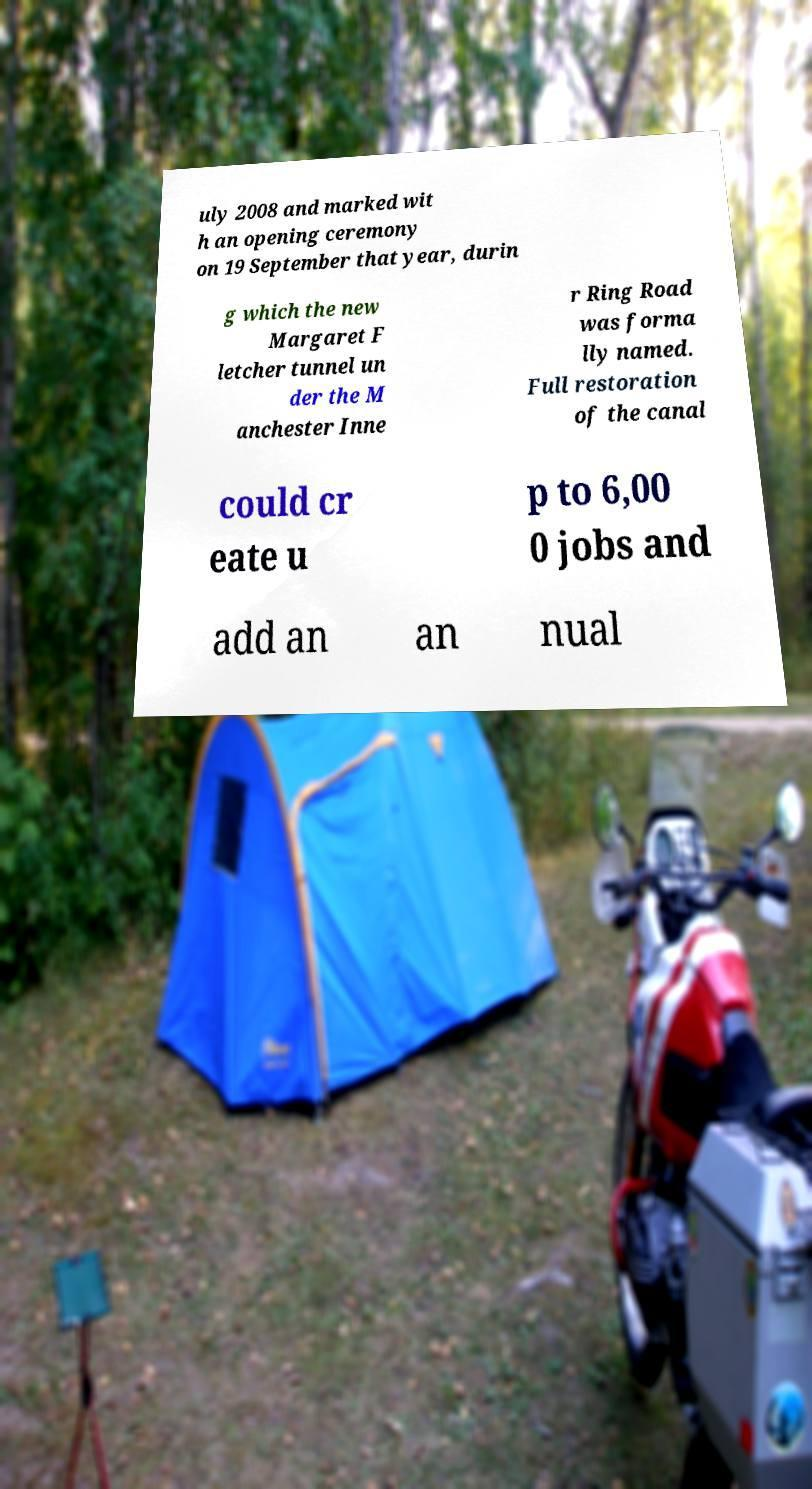Can you accurately transcribe the text from the provided image for me? uly 2008 and marked wit h an opening ceremony on 19 September that year, durin g which the new Margaret F letcher tunnel un der the M anchester Inne r Ring Road was forma lly named. Full restoration of the canal could cr eate u p to 6,00 0 jobs and add an an nual 